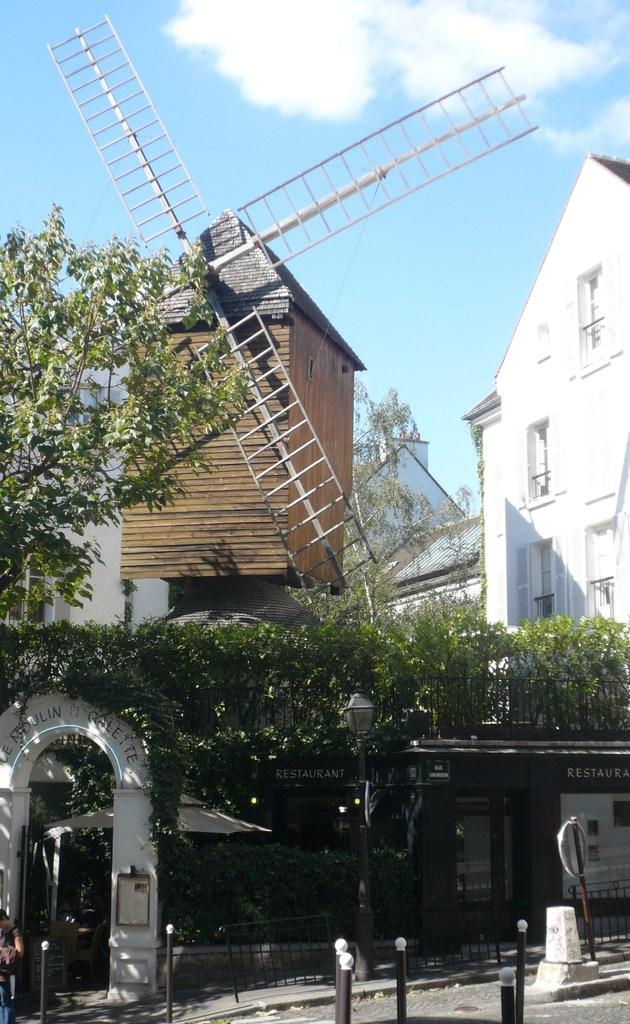What is the main structure visible in the image? There is a windmill in the image. What other types of structures can be seen in the image? There are buildings in the image. What natural elements are present in the image? There are trees in the image. What type of material is used for the rods in the image? Metal rods are present in the image. What type of barrier is visible in the image? There is a fence in the image. Can you see any boats in the harbor in the image? There is no harbor or boats present in the image. What type of chess piece is located on the top of the windmill in the image? There is no chess piece or reference to a chess game in the image. 